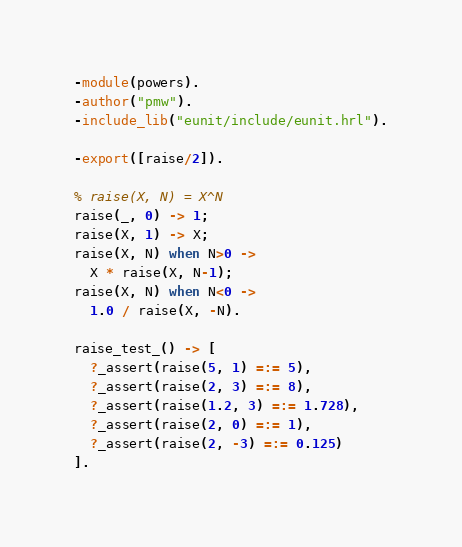<code> <loc_0><loc_0><loc_500><loc_500><_Erlang_>-module(powers).
-author("pmw").
-include_lib("eunit/include/eunit.hrl").

-export([raise/2]).

% raise(X, N) = X^N
raise(_, 0) -> 1;
raise(X, 1) -> X;
raise(X, N) when N>0 ->
  X * raise(X, N-1);
raise(X, N) when N<0 ->
  1.0 / raise(X, -N).

raise_test_() -> [
  ?_assert(raise(5, 1) =:= 5),
  ?_assert(raise(2, 3) =:= 8),
  ?_assert(raise(1.2, 3) =:= 1.728),
  ?_assert(raise(2, 0) =:= 1),
  ?_assert(raise(2, -3) =:= 0.125)
].
</code> 